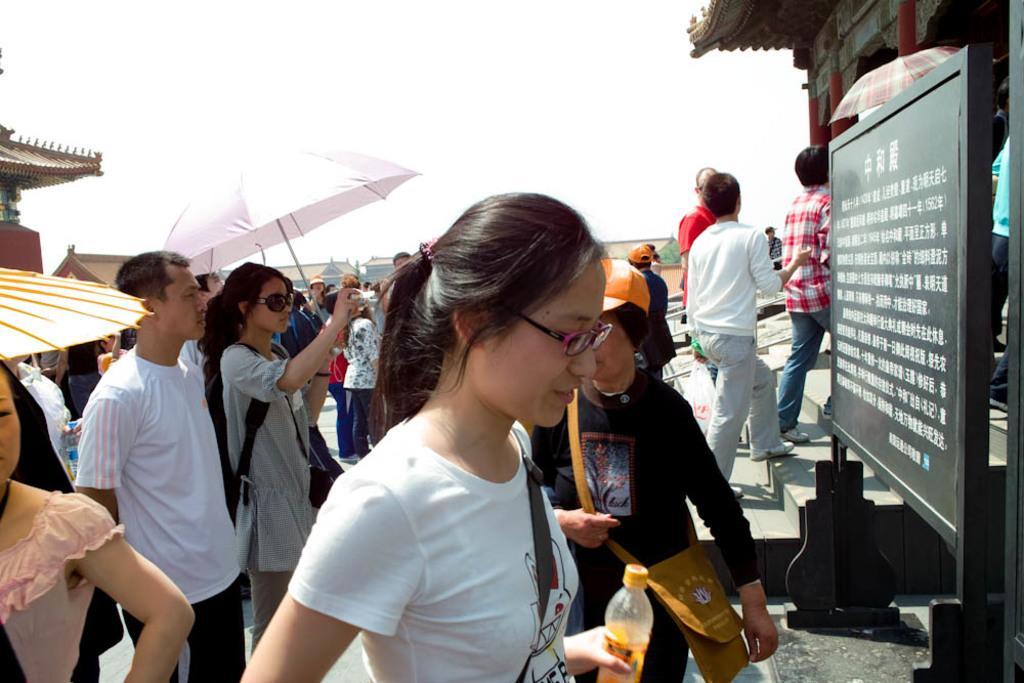Please provide a concise description of this image. There are many people. Some are wearing bags, goggles, caps and holding umbrellas. On the right side there is a board. Lady in the front is holding a bottle. On the right side there is a board. In the background there is sky. On the sides there is a building. 